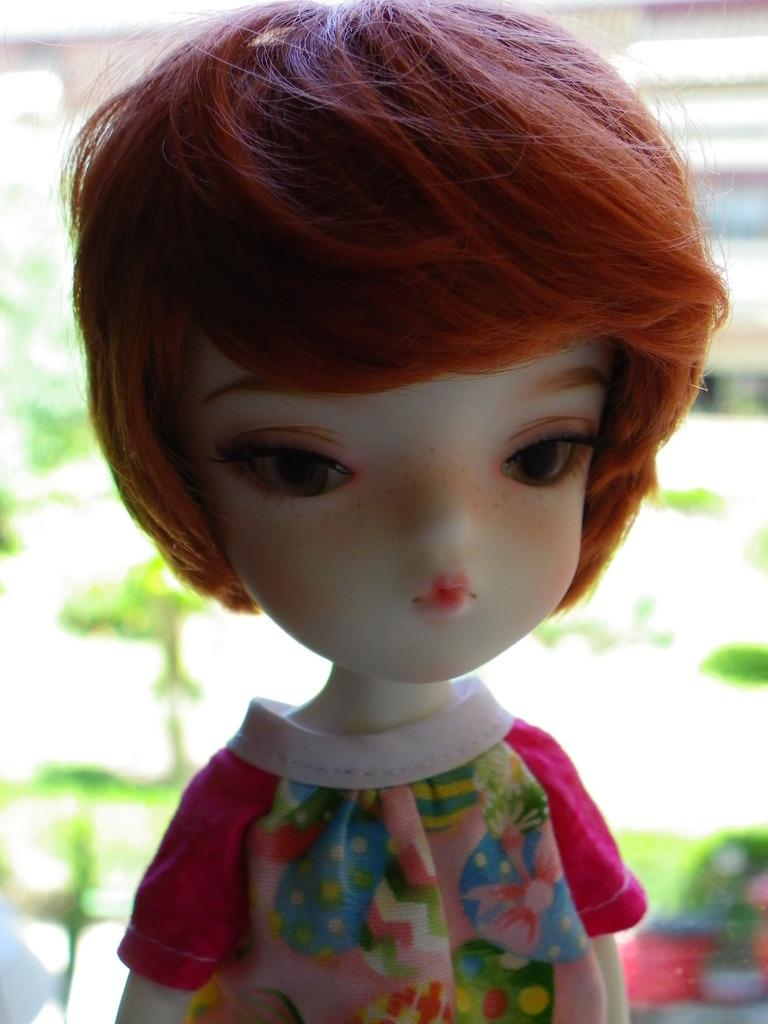What is the main subject of the image? There is a doll in the image. What is the doll wearing? The doll is wearing a pink dress. What can be seen in the background of the image? There are trees and buildings in the background of the image. How is the background of the image depicted? The background of the image is blurred. What type of whistle can be heard in the background of the image? There is no whistle present in the image, as it is a still image and does not contain any sounds. 